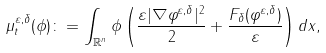<formula> <loc_0><loc_0><loc_500><loc_500>\mu _ { t } ^ { \varepsilon , \delta } ( \phi ) \colon = \int _ { \mathbb { R } ^ { n } } \phi \left ( \frac { \varepsilon | \nabla \varphi ^ { \varepsilon , \delta } | ^ { 2 } } { 2 } + \frac { F _ { \delta } ( \varphi ^ { \varepsilon , \delta } ) } { \varepsilon } \right ) d x ,</formula> 